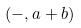<formula> <loc_0><loc_0><loc_500><loc_500>( - , a + b )</formula> 